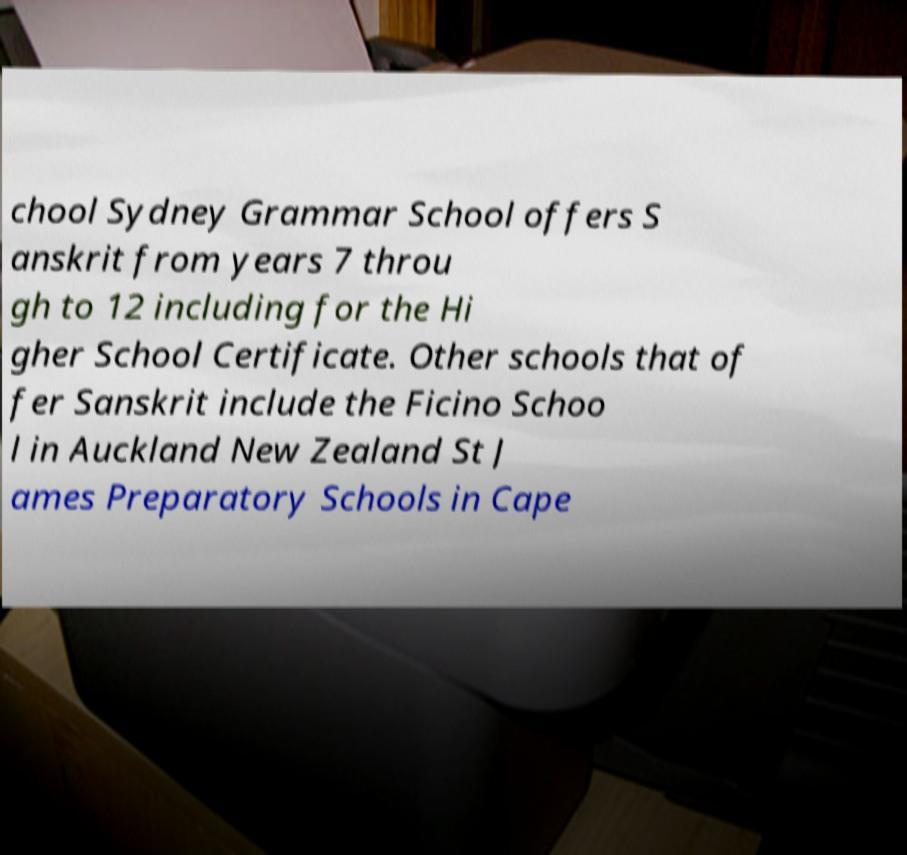For documentation purposes, I need the text within this image transcribed. Could you provide that? chool Sydney Grammar School offers S anskrit from years 7 throu gh to 12 including for the Hi gher School Certificate. Other schools that of fer Sanskrit include the Ficino Schoo l in Auckland New Zealand St J ames Preparatory Schools in Cape 